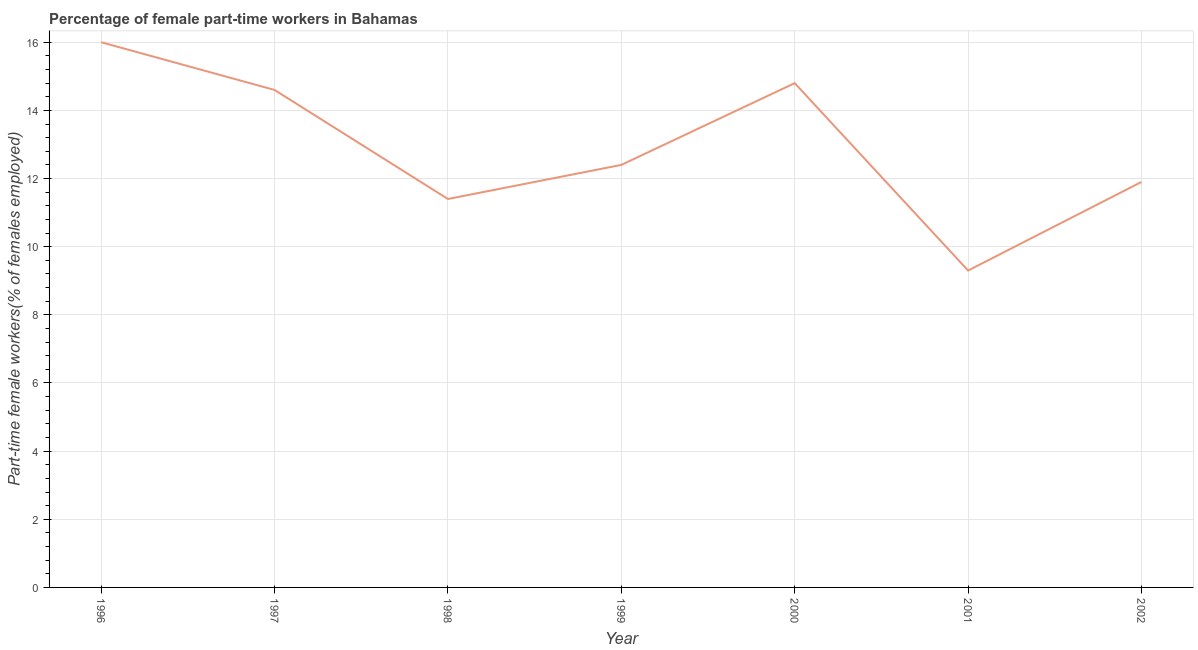What is the percentage of part-time female workers in 1996?
Make the answer very short. 16. Across all years, what is the minimum percentage of part-time female workers?
Give a very brief answer. 9.3. In which year was the percentage of part-time female workers minimum?
Your response must be concise. 2001. What is the sum of the percentage of part-time female workers?
Keep it short and to the point. 90.4. What is the difference between the percentage of part-time female workers in 1997 and 1998?
Provide a short and direct response. 3.2. What is the average percentage of part-time female workers per year?
Offer a terse response. 12.91. What is the median percentage of part-time female workers?
Give a very brief answer. 12.4. In how many years, is the percentage of part-time female workers greater than 2 %?
Provide a short and direct response. 7. Do a majority of the years between 2000 and 2002 (inclusive) have percentage of part-time female workers greater than 6 %?
Provide a succinct answer. Yes. What is the ratio of the percentage of part-time female workers in 1998 to that in 2002?
Make the answer very short. 0.96. Is the percentage of part-time female workers in 1996 less than that in 2000?
Ensure brevity in your answer.  No. What is the difference between the highest and the second highest percentage of part-time female workers?
Provide a short and direct response. 1.2. Is the sum of the percentage of part-time female workers in 1999 and 2001 greater than the maximum percentage of part-time female workers across all years?
Make the answer very short. Yes. What is the difference between the highest and the lowest percentage of part-time female workers?
Your answer should be compact. 6.7. In how many years, is the percentage of part-time female workers greater than the average percentage of part-time female workers taken over all years?
Provide a short and direct response. 3. Does the percentage of part-time female workers monotonically increase over the years?
Provide a succinct answer. No. Are the values on the major ticks of Y-axis written in scientific E-notation?
Give a very brief answer. No. What is the title of the graph?
Offer a terse response. Percentage of female part-time workers in Bahamas. What is the label or title of the X-axis?
Offer a terse response. Year. What is the label or title of the Y-axis?
Your response must be concise. Part-time female workers(% of females employed). What is the Part-time female workers(% of females employed) of 1996?
Keep it short and to the point. 16. What is the Part-time female workers(% of females employed) in 1997?
Make the answer very short. 14.6. What is the Part-time female workers(% of females employed) of 1998?
Offer a very short reply. 11.4. What is the Part-time female workers(% of females employed) in 1999?
Offer a terse response. 12.4. What is the Part-time female workers(% of females employed) of 2000?
Provide a short and direct response. 14.8. What is the Part-time female workers(% of females employed) in 2001?
Keep it short and to the point. 9.3. What is the Part-time female workers(% of females employed) in 2002?
Your response must be concise. 11.9. What is the difference between the Part-time female workers(% of females employed) in 1996 and 1998?
Make the answer very short. 4.6. What is the difference between the Part-time female workers(% of females employed) in 1996 and 1999?
Give a very brief answer. 3.6. What is the difference between the Part-time female workers(% of females employed) in 1996 and 2001?
Provide a short and direct response. 6.7. What is the difference between the Part-time female workers(% of females employed) in 1996 and 2002?
Offer a very short reply. 4.1. What is the difference between the Part-time female workers(% of females employed) in 1997 and 1998?
Make the answer very short. 3.2. What is the difference between the Part-time female workers(% of females employed) in 1997 and 1999?
Provide a succinct answer. 2.2. What is the difference between the Part-time female workers(% of females employed) in 1997 and 2000?
Offer a terse response. -0.2. What is the difference between the Part-time female workers(% of females employed) in 1997 and 2001?
Provide a short and direct response. 5.3. What is the difference between the Part-time female workers(% of females employed) in 1998 and 2000?
Give a very brief answer. -3.4. What is the difference between the Part-time female workers(% of females employed) in 1998 and 2001?
Your answer should be very brief. 2.1. What is the difference between the Part-time female workers(% of females employed) in 1998 and 2002?
Your answer should be compact. -0.5. What is the difference between the Part-time female workers(% of females employed) in 1999 and 2001?
Give a very brief answer. 3.1. What is the difference between the Part-time female workers(% of females employed) in 2000 and 2002?
Ensure brevity in your answer.  2.9. What is the difference between the Part-time female workers(% of females employed) in 2001 and 2002?
Your response must be concise. -2.6. What is the ratio of the Part-time female workers(% of females employed) in 1996 to that in 1997?
Ensure brevity in your answer.  1.1. What is the ratio of the Part-time female workers(% of females employed) in 1996 to that in 1998?
Ensure brevity in your answer.  1.4. What is the ratio of the Part-time female workers(% of females employed) in 1996 to that in 1999?
Give a very brief answer. 1.29. What is the ratio of the Part-time female workers(% of females employed) in 1996 to that in 2000?
Offer a very short reply. 1.08. What is the ratio of the Part-time female workers(% of females employed) in 1996 to that in 2001?
Offer a terse response. 1.72. What is the ratio of the Part-time female workers(% of females employed) in 1996 to that in 2002?
Make the answer very short. 1.34. What is the ratio of the Part-time female workers(% of females employed) in 1997 to that in 1998?
Your answer should be compact. 1.28. What is the ratio of the Part-time female workers(% of females employed) in 1997 to that in 1999?
Give a very brief answer. 1.18. What is the ratio of the Part-time female workers(% of females employed) in 1997 to that in 2000?
Offer a very short reply. 0.99. What is the ratio of the Part-time female workers(% of females employed) in 1997 to that in 2001?
Your response must be concise. 1.57. What is the ratio of the Part-time female workers(% of females employed) in 1997 to that in 2002?
Keep it short and to the point. 1.23. What is the ratio of the Part-time female workers(% of females employed) in 1998 to that in 1999?
Your answer should be compact. 0.92. What is the ratio of the Part-time female workers(% of females employed) in 1998 to that in 2000?
Your answer should be very brief. 0.77. What is the ratio of the Part-time female workers(% of females employed) in 1998 to that in 2001?
Make the answer very short. 1.23. What is the ratio of the Part-time female workers(% of females employed) in 1998 to that in 2002?
Offer a very short reply. 0.96. What is the ratio of the Part-time female workers(% of females employed) in 1999 to that in 2000?
Provide a short and direct response. 0.84. What is the ratio of the Part-time female workers(% of females employed) in 1999 to that in 2001?
Give a very brief answer. 1.33. What is the ratio of the Part-time female workers(% of females employed) in 1999 to that in 2002?
Make the answer very short. 1.04. What is the ratio of the Part-time female workers(% of females employed) in 2000 to that in 2001?
Your answer should be compact. 1.59. What is the ratio of the Part-time female workers(% of females employed) in 2000 to that in 2002?
Offer a very short reply. 1.24. What is the ratio of the Part-time female workers(% of females employed) in 2001 to that in 2002?
Offer a very short reply. 0.78. 